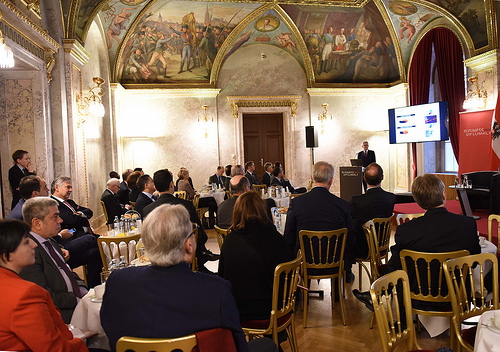<image>
Can you confirm if the man is on the chair? Yes. Looking at the image, I can see the man is positioned on top of the chair, with the chair providing support. 